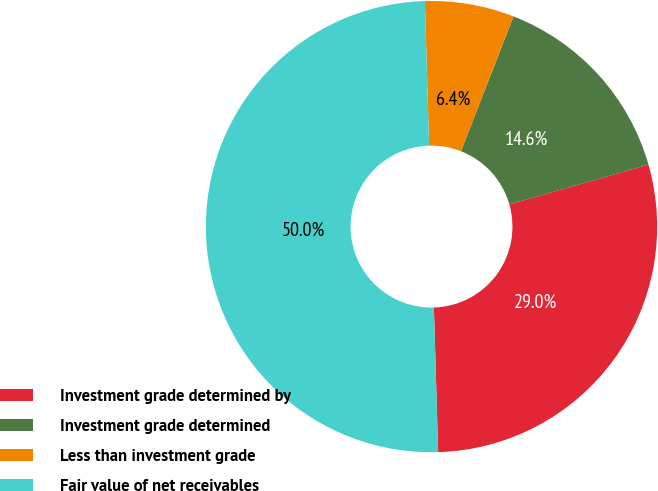Convert chart. <chart><loc_0><loc_0><loc_500><loc_500><pie_chart><fcel>Investment grade determined by<fcel>Investment grade determined<fcel>Less than investment grade<fcel>Fair value of net receivables<nl><fcel>28.96%<fcel>14.65%<fcel>6.39%<fcel>50.0%<nl></chart> 